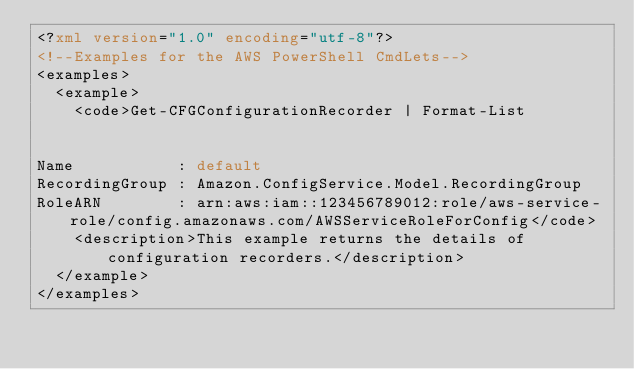<code> <loc_0><loc_0><loc_500><loc_500><_XML_><?xml version="1.0" encoding="utf-8"?>
<!--Examples for the AWS PowerShell CmdLets-->
<examples>
  <example>
    <code>Get-CFGConfigurationRecorder | Format-List


Name           : default
RecordingGroup : Amazon.ConfigService.Model.RecordingGroup
RoleARN        : arn:aws:iam::123456789012:role/aws-service-role/config.amazonaws.com/AWSServiceRoleForConfig</code>
    <description>This example returns the details of configuration recorders.</description>
  </example>
</examples></code> 